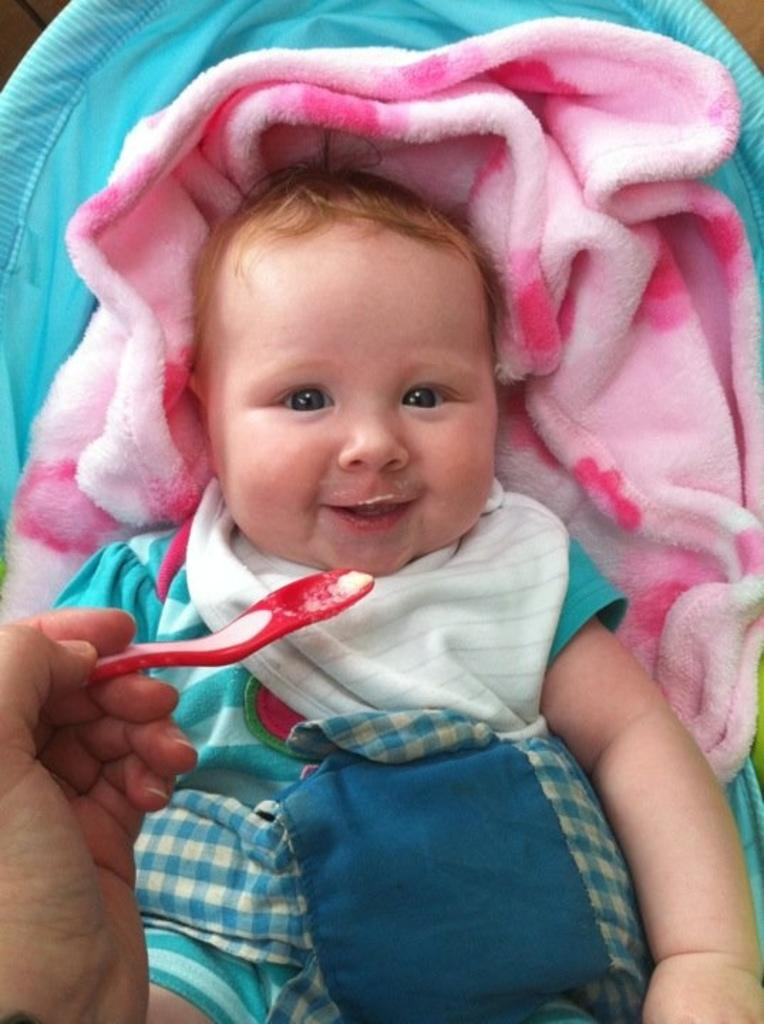What is the main subject of the image? The main subject of the image is a baby. What is the baby doing in the image? The baby is smiling in the image. What is the baby wearing? The baby is wearing a blue dress. Who is interacting with the baby in the image? Someone is feeding the baby with a spoon. What is under the baby in the image? There is a pink cloth under the baby. How many cacti are visible in the image? There are no cacti present in the image. What are the men in the image discussing? There are no men present in the image. 